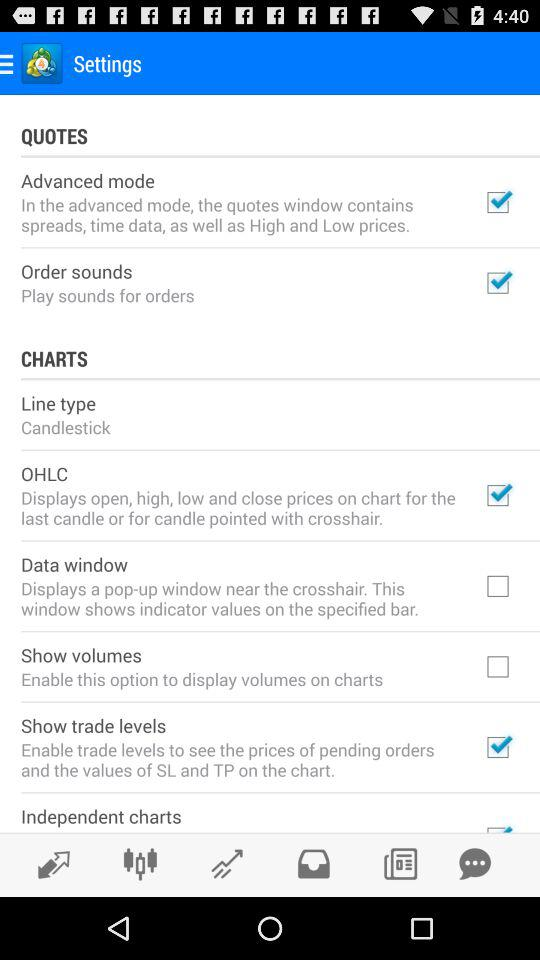What is the status of OHLC? The status is on. 